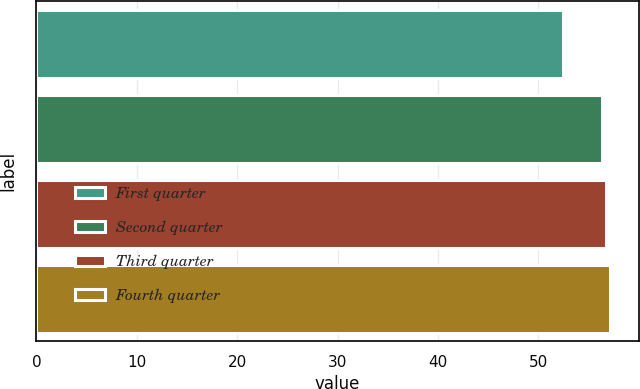Convert chart to OTSL. <chart><loc_0><loc_0><loc_500><loc_500><bar_chart><fcel>First quarter<fcel>Second quarter<fcel>Third quarter<fcel>Fourth quarter<nl><fcel>52.47<fcel>56.31<fcel>56.72<fcel>57.13<nl></chart> 